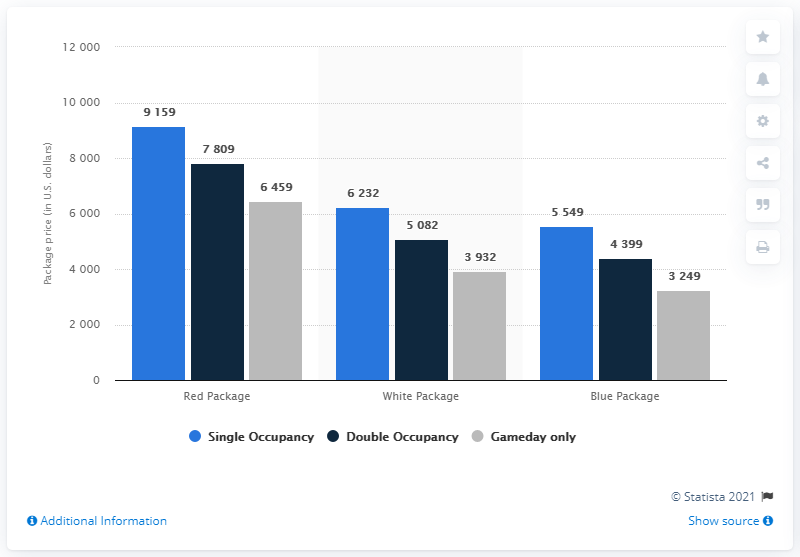Specify some key components in this picture. The difference between the two least gray bars is 683. The maximum value that can be achieved by the Red package is 9159. 